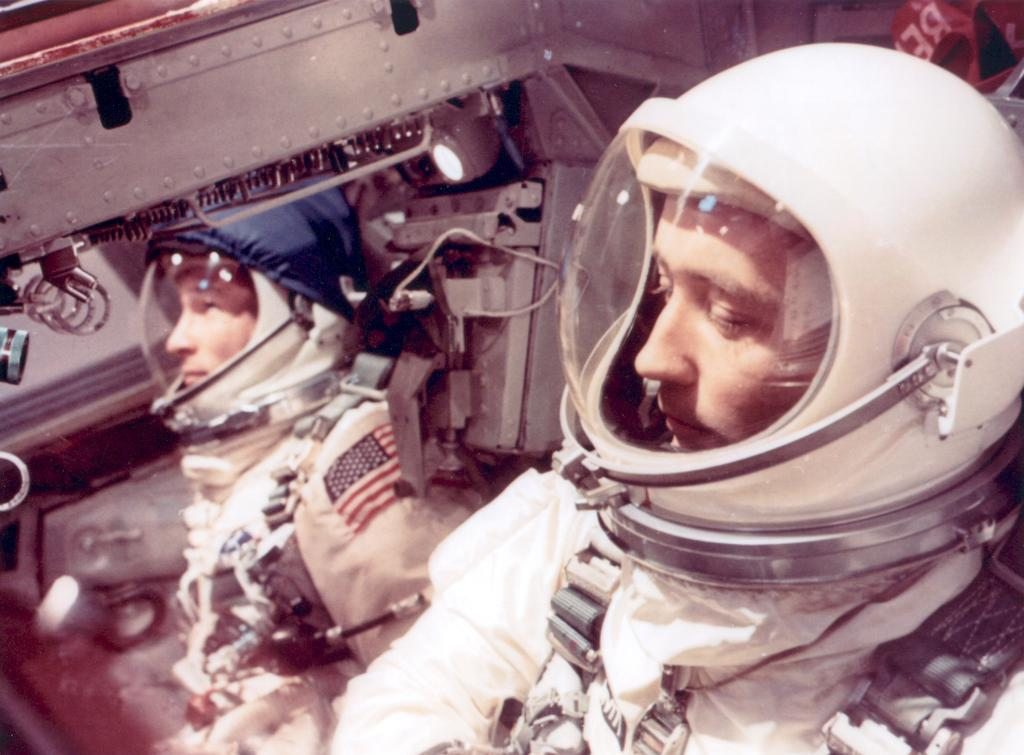How many people are in the image? There are two men in the image. What are the men doing in the image? The men are sitting in a spaceship. What type of clothing are the men wearing? The men are wearing space suits. What type of plant is growing inside the spaceship in the image? There is no plant visible in the image; the men are sitting in a spaceship wearing space suits. 